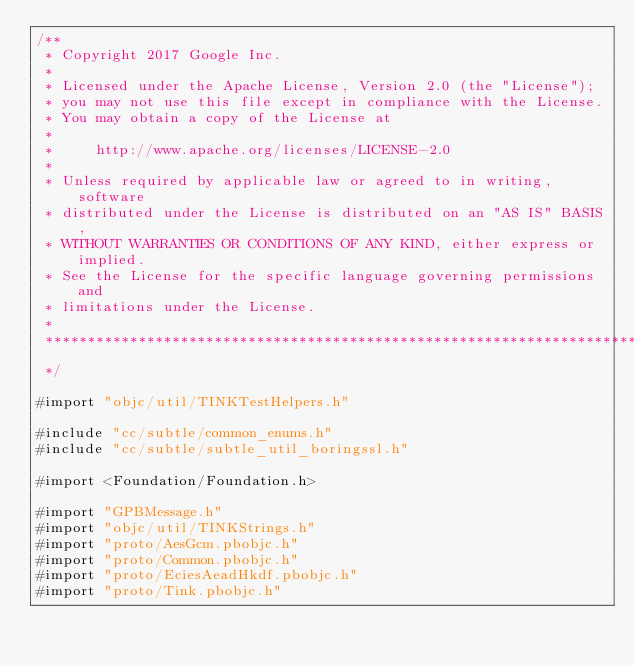<code> <loc_0><loc_0><loc_500><loc_500><_ObjectiveC_>/**
 * Copyright 2017 Google Inc.
 *
 * Licensed under the Apache License, Version 2.0 (the "License");
 * you may not use this file except in compliance with the License.
 * You may obtain a copy of the License at
 *
 *     http://www.apache.org/licenses/LICENSE-2.0
 *
 * Unless required by applicable law or agreed to in writing, software
 * distributed under the License is distributed on an "AS IS" BASIS,
 * WITHOUT WARRANTIES OR CONDITIONS OF ANY KIND, either express or implied.
 * See the License for the specific language governing permissions and
 * limitations under the License.
 *
 **************************************************************************
 */

#import "objc/util/TINKTestHelpers.h"

#include "cc/subtle/common_enums.h"
#include "cc/subtle/subtle_util_boringssl.h"

#import <Foundation/Foundation.h>

#import "GPBMessage.h"
#import "objc/util/TINKStrings.h"
#import "proto/AesGcm.pbobjc.h"
#import "proto/Common.pbobjc.h"
#import "proto/EciesAeadHkdf.pbobjc.h"
#import "proto/Tink.pbobjc.h"
</code> 